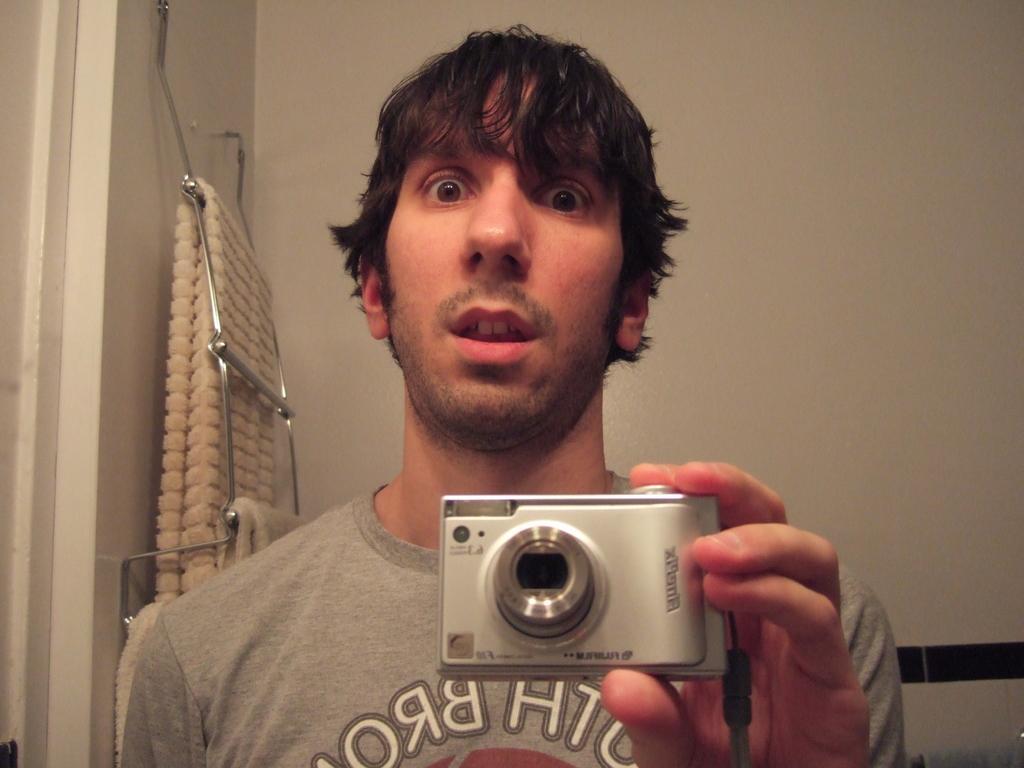How would you summarize this image in a sentence or two? In this picture I can see a man standing and holding camera in his hands. At background I can see a blanket hanging to the hanger. 